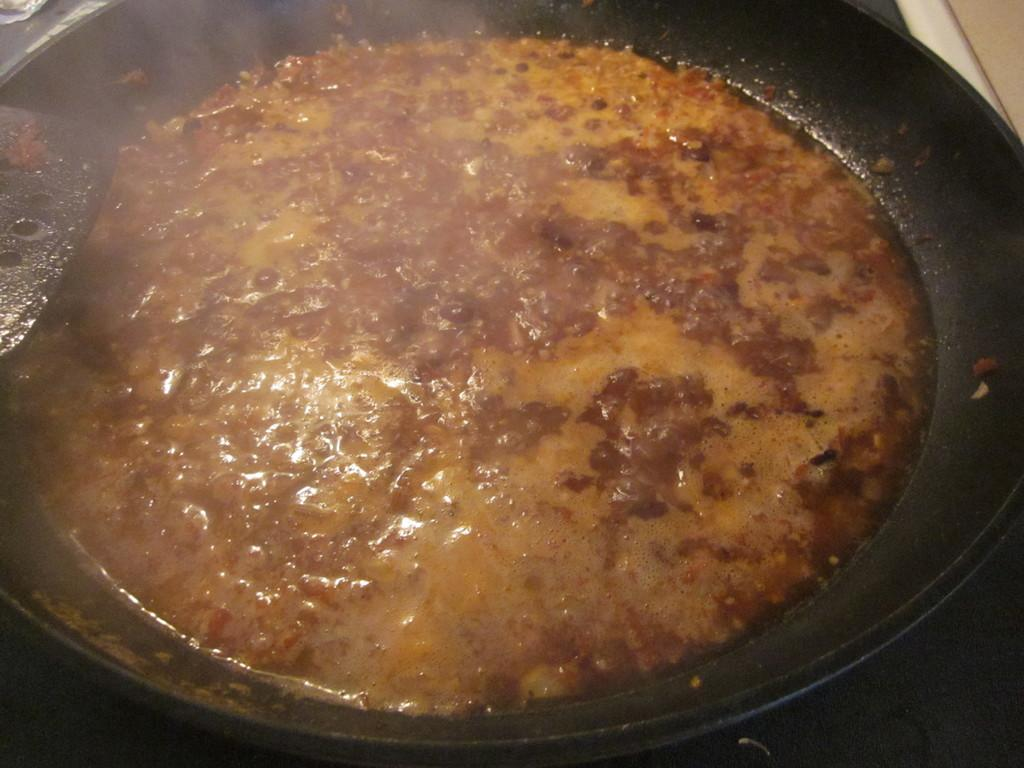What is in the pan that is visible in the image? There is a pan containing food in the image. Where might the pan be placed in the image? The pan might be placed on a gas stove. What utensil is visible on the left side of the image? There is a spoon on the left side of the image. Can you tell me how many baseballs are visible in the image? There are no baseballs present in the image. What type of watch is being worn by the person in the image? There is no person or watch visible in the image. 